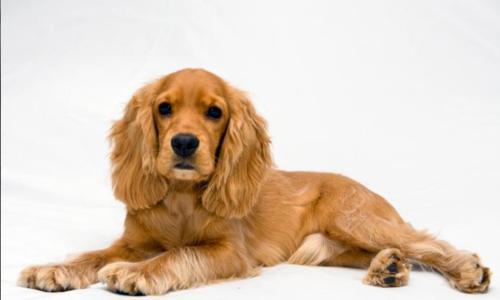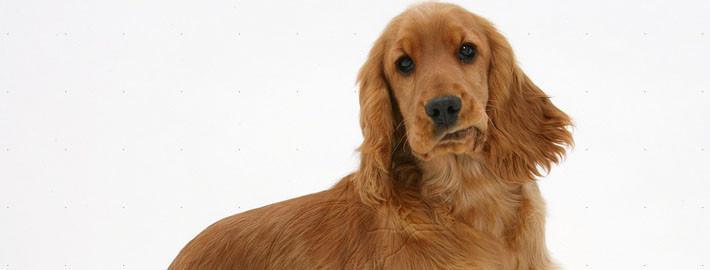The first image is the image on the left, the second image is the image on the right. Analyze the images presented: Is the assertion "The tongue is out on one of the dog." valid? Answer yes or no. No. The first image is the image on the left, the second image is the image on the right. Given the left and right images, does the statement "An image shows a spaniel looking upward to the right." hold true? Answer yes or no. No. 